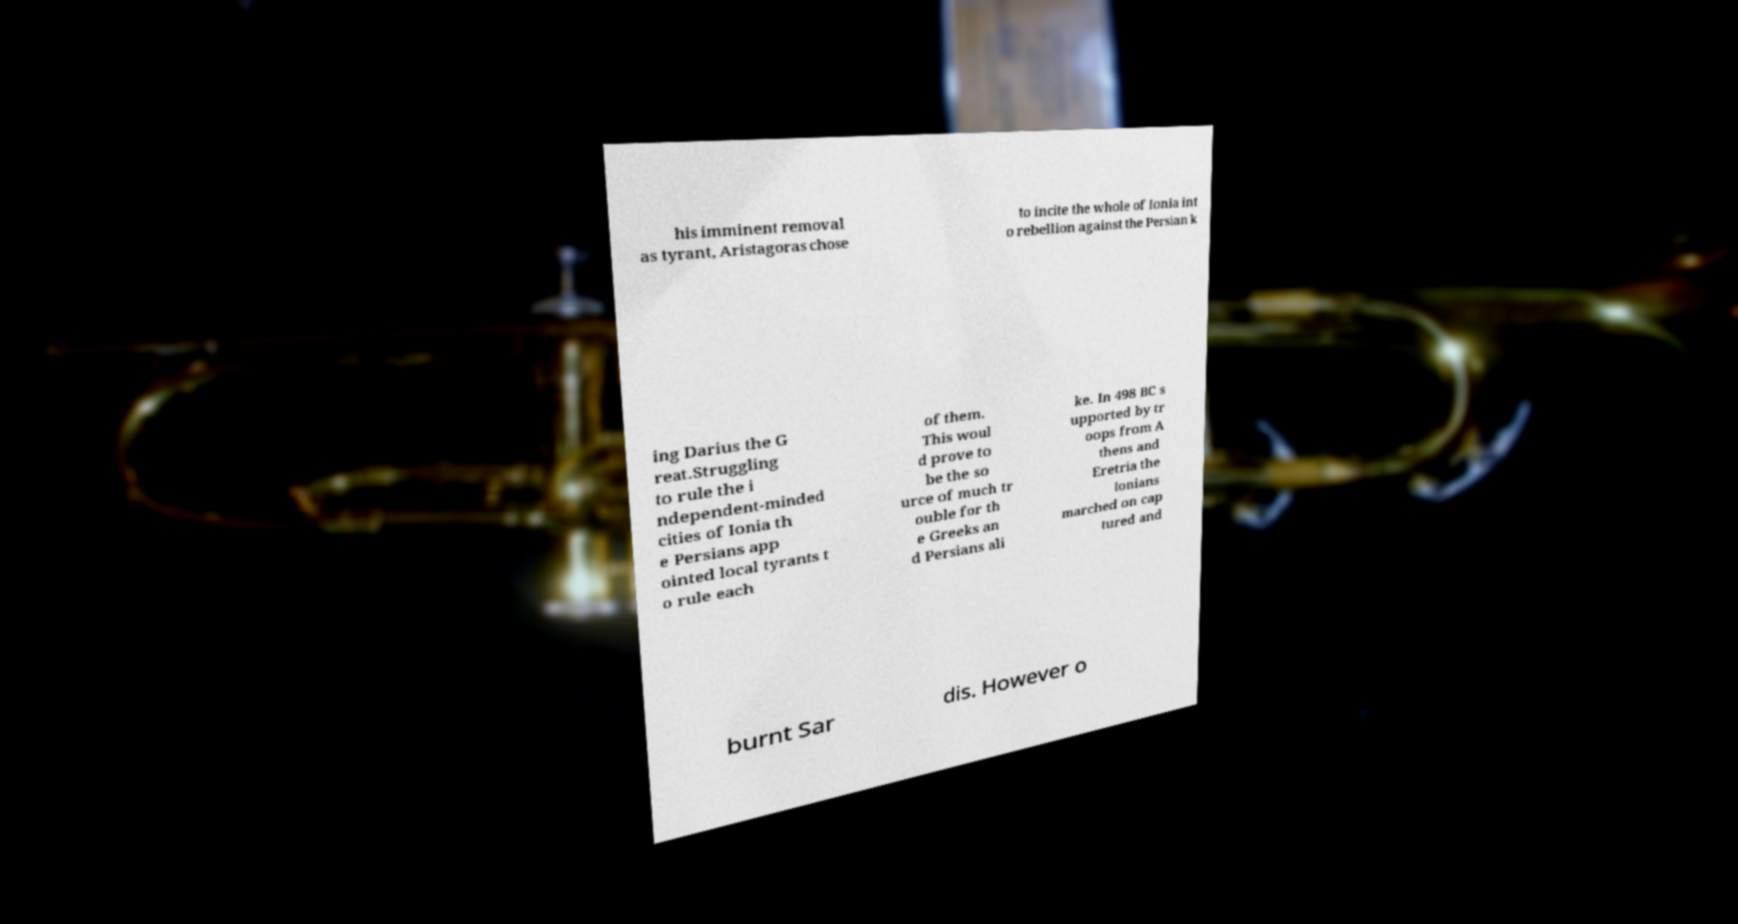There's text embedded in this image that I need extracted. Can you transcribe it verbatim? his imminent removal as tyrant, Aristagoras chose to incite the whole of Ionia int o rebellion against the Persian k ing Darius the G reat.Struggling to rule the i ndependent-minded cities of Ionia th e Persians app ointed local tyrants t o rule each of them. This woul d prove to be the so urce of much tr ouble for th e Greeks an d Persians ali ke. In 498 BC s upported by tr oops from A thens and Eretria the Ionians marched on cap tured and burnt Sar dis. However o 